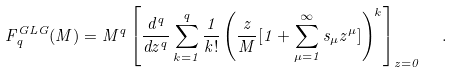Convert formula to latex. <formula><loc_0><loc_0><loc_500><loc_500>F _ { q } ^ { G L G } ( M ) = M ^ { q } \left [ \frac { d ^ { q } } { d z ^ { q } } \sum _ { k = 1 } ^ { q } \frac { 1 } { k ! } \left ( \frac { z } { M } [ 1 + \sum _ { \mu = 1 } ^ { \infty } s _ { \mu } z ^ { \mu } ] \right ) ^ { k } \right ] _ { z = 0 } \ \ .</formula> 